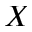<formula> <loc_0><loc_0><loc_500><loc_500>X</formula> 